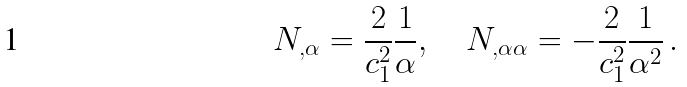<formula> <loc_0><loc_0><loc_500><loc_500>N _ { , \alpha } = \frac { 2 } { c _ { 1 } ^ { 2 } } \frac { 1 } { \alpha } , \quad N _ { , \alpha \alpha } = - \frac { 2 } { c _ { 1 } ^ { 2 } } \frac { 1 } { \alpha ^ { 2 } } \, .</formula> 